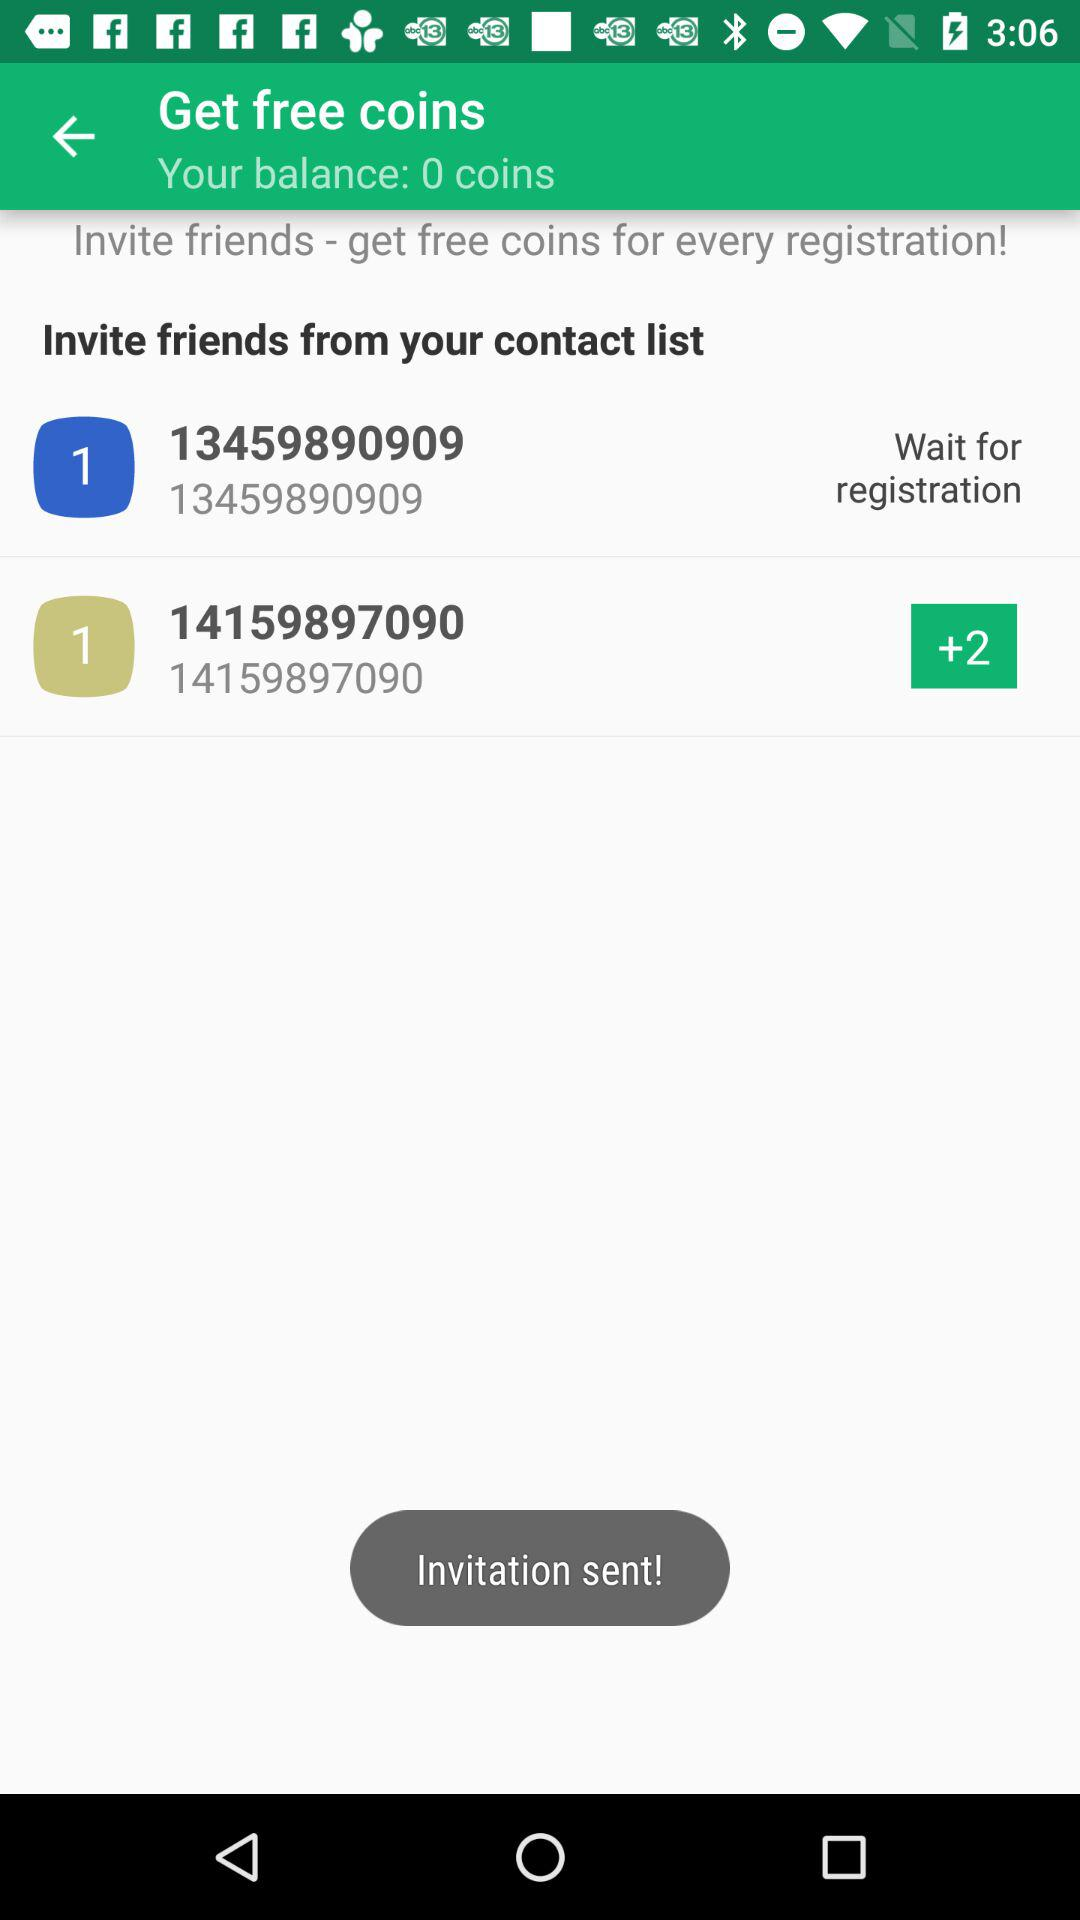How many coins do you have?
Answer the question using a single word or phrase. 0 